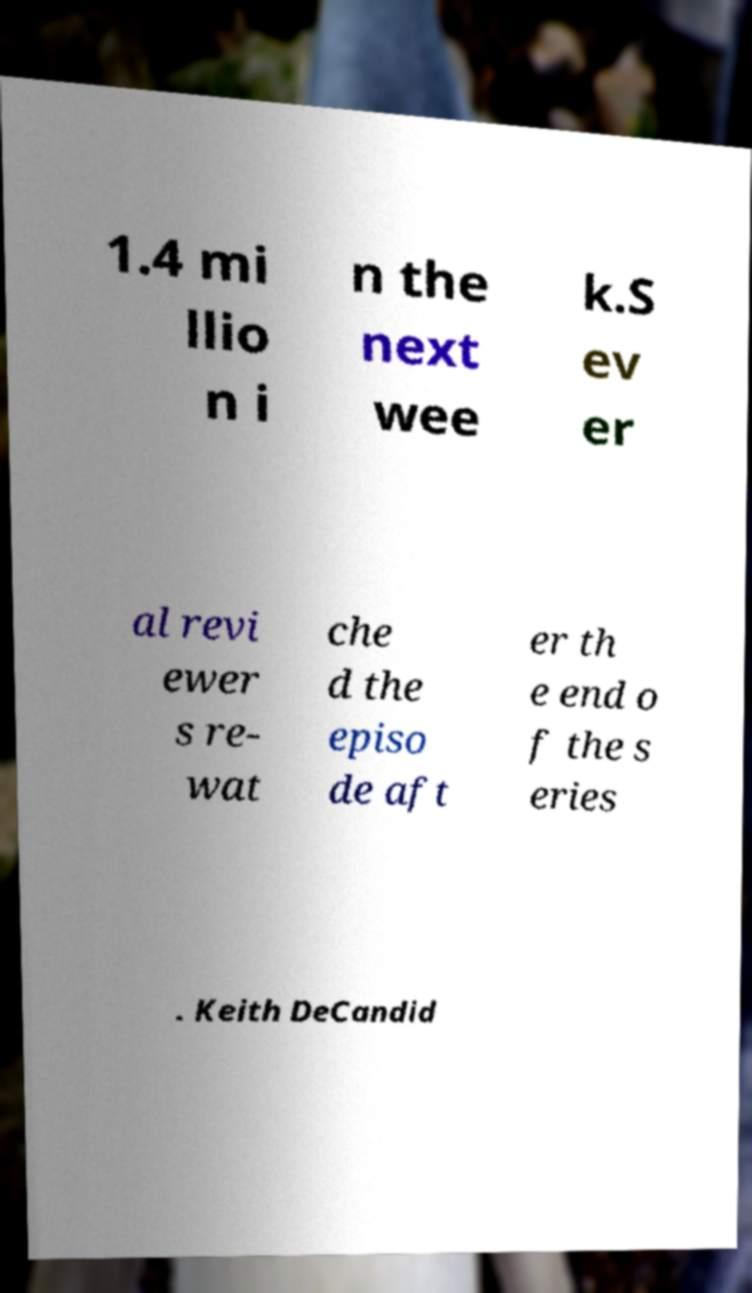I need the written content from this picture converted into text. Can you do that? 1.4 mi llio n i n the next wee k.S ev er al revi ewer s re- wat che d the episo de aft er th e end o f the s eries . Keith DeCandid 